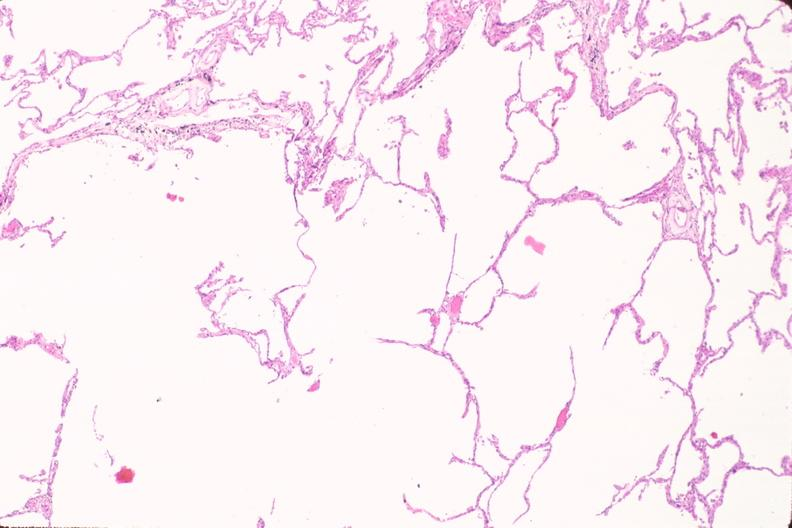does this image show lung, emphysema in a chronic smoker?
Answer the question using a single word or phrase. Yes 